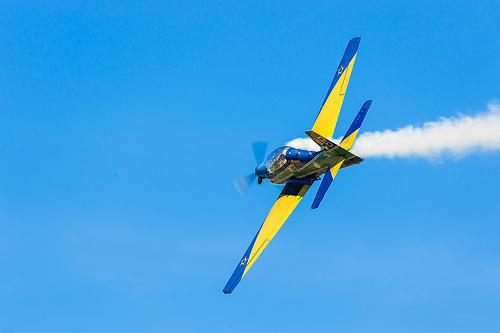Question: when was this picture taken?
Choices:
A. At night.
B. In the morning.
C. In the evening.
D. During the day.
Answer with the letter. Answer: D Question: what is coming out of the plane?
Choices:
A. Vapor.
B. Fumes.
C. Gas.
D. Smoke.
Answer with the letter. Answer: D 